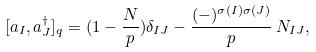Convert formula to latex. <formula><loc_0><loc_0><loc_500><loc_500>[ a _ { I } , a ^ { \dagger } _ { J } ] _ { q } = ( 1 - \frac { N } { p } ) \delta _ { I J } - \frac { ( - ) ^ { \sigma ( I ) \sigma ( J ) } } { p } \, N _ { I J } ,</formula> 